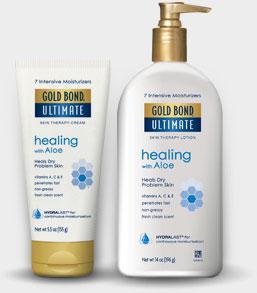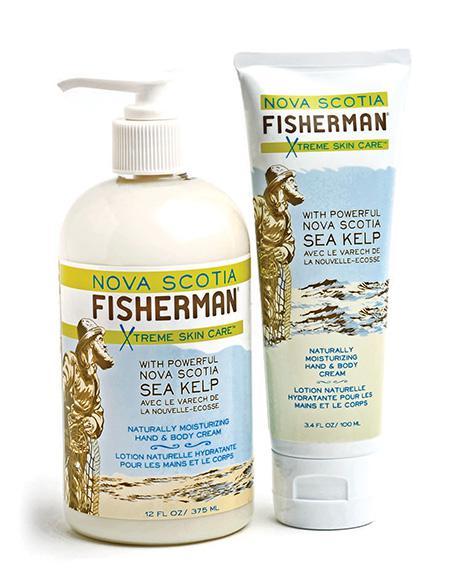The first image is the image on the left, the second image is the image on the right. Examine the images to the left and right. Is the description "Each image shows one sunscreen product standing to the right of the box the product is packaged in to be sold." accurate? Answer yes or no. No. The first image is the image on the left, the second image is the image on the right. Analyze the images presented: Is the assertion "Each image shows one skincare product next to its box." valid? Answer yes or no. No. 